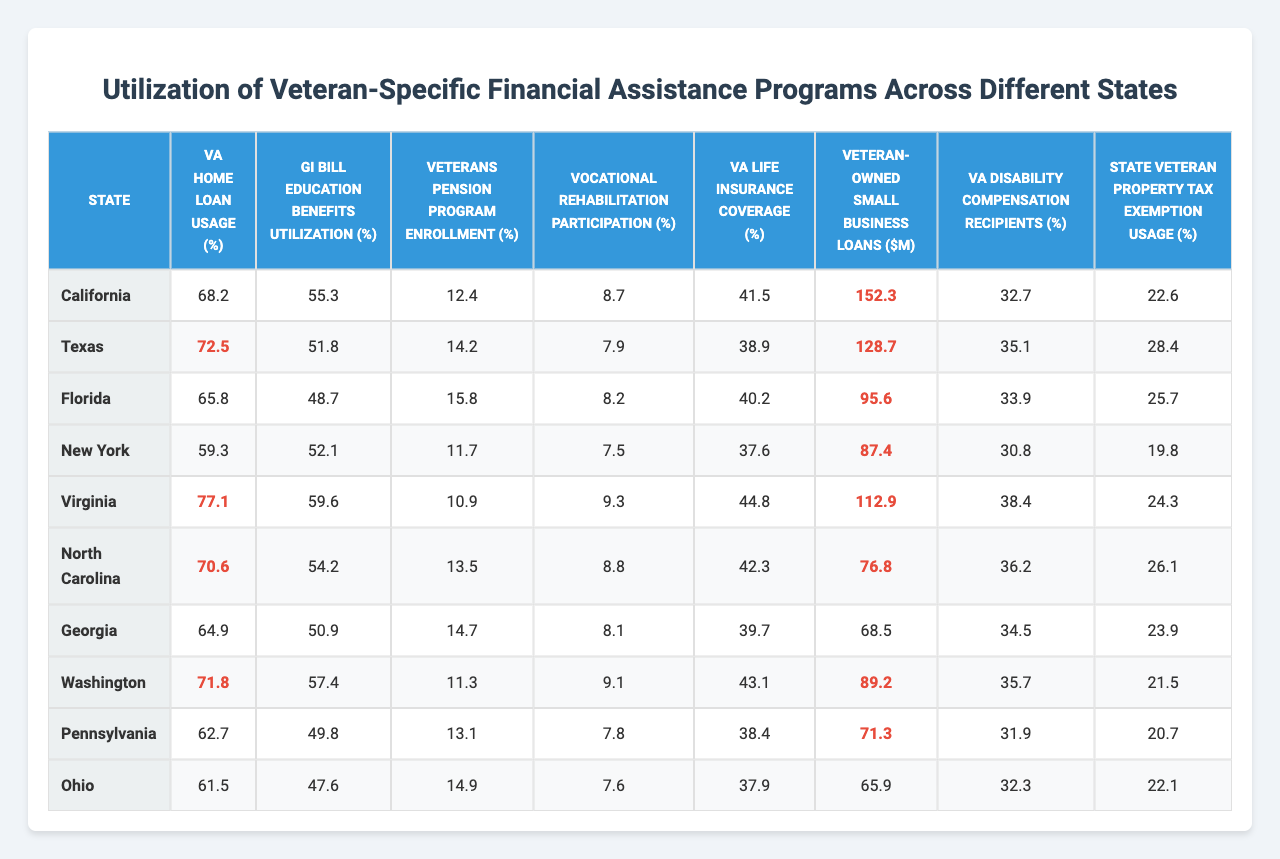What state has the highest VA Home Loan Usage percentage? Referring to the table, California has the highest VA Home Loan Usage at 68.2%.
Answer: California What is the average GI Bill Education Benefits Utilization percentage across the states listed? Adding the utilization percentages (55.3 + 51.8 + 48.7 + 52.1 + 59.6 + 54.2 + 50.9 + 57.4 + 49.8 + 47.6) gives a total of 468.4, and dividing that by 10 states results in an average of 46.84%.
Answer: 46.84% Which state has the lowest participation in the Vocational Rehabilitation Program? By inspecting the table, New York at 7.5% shows the lowest participation in the Vocational Rehabilitation Program.
Answer: New York True or False: Texas has a higher Veterans Pension Program Enrollment percentage than Virginia. The table indicates Texas at 14.2% and Virginia at 10.9%, confirming that Texas has a higher percentage.
Answer: True Which state has the highest percentage of VA Life Insurance Coverage and how much is it? The highest VA Life Insurance Coverage is in Virginia at 44.8%.
Answer: Virginia, 44.8% What is the difference in VA Home Loan Usage between the state with the highest percentage and the state with the lowest? California has the highest (68.2%) and Texas has the lowest (61.5%); the difference is 68.2 - 61.5 = 6.7%.
Answer: 6.7% What is the total amount of Veteran-Owned Small Business Loans across all states? Summing the values shows (152.3 + 128.7 + 95.6 + 87.4 + 112.9 + 76.8 + 68.5 + 89.2 + 71.3 + 65.9) equals 988.6 million dollars.
Answer: 988.6 million Which state has the least utilization of the State Veteran Property Tax Exemption? The table shows New York at 19.8%, which is the lowest utilization of the State Veteran Property Tax Exemption.
Answer: New York How does the VA Disability Compensation Recipients percentage in Ohio compare to the national average if the average were calculated here? Ohio has a VA Disability Compensation Recipients percentage of 32.3%. The average across ten states would require calculating the average from the list (32.7, 35.1, 33.9, 30.8, 38.4, 36.2, 34.5, 35.7, 31.9, 32.3) yielding a result around 33.49%, indicating Ohio is slightly below average.
Answer: Below average What is the ratio of Veterans Pension Program Enrollment in Georgia to the same in Florida? Georgia has an enrollment of 14.7% and Florida has 15.8%; the ratio is 14.7/15.8 = 0.93, which shows Georgia has approximately 93% the enrollment of Florida.
Answer: 0.93 